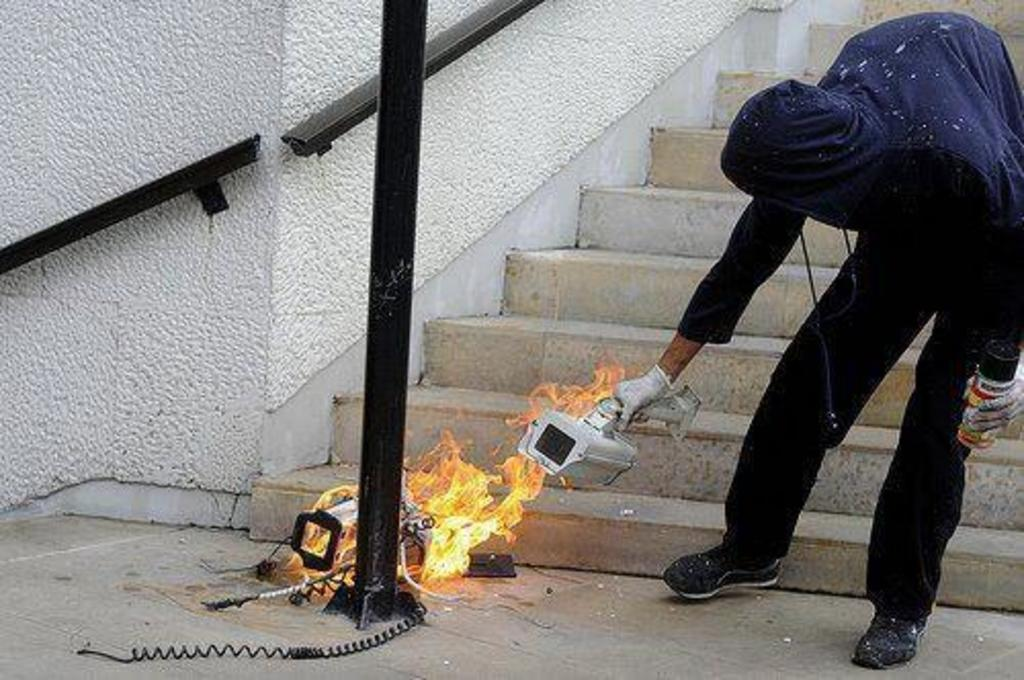What is the person in the image holding? The person is holding a CCTV in the image. What can be seen supporting the CCTV? There is a pole in the image. What is happening in the middle of the image? There is fire in the middle of the image. What architectural feature is visible in the background of the image? There are stairs in the background of the image. What type of toothpaste is being used to extinguish the fire in the image? There is no toothpaste present in the image, and toothpaste is not used to extinguish fires. 